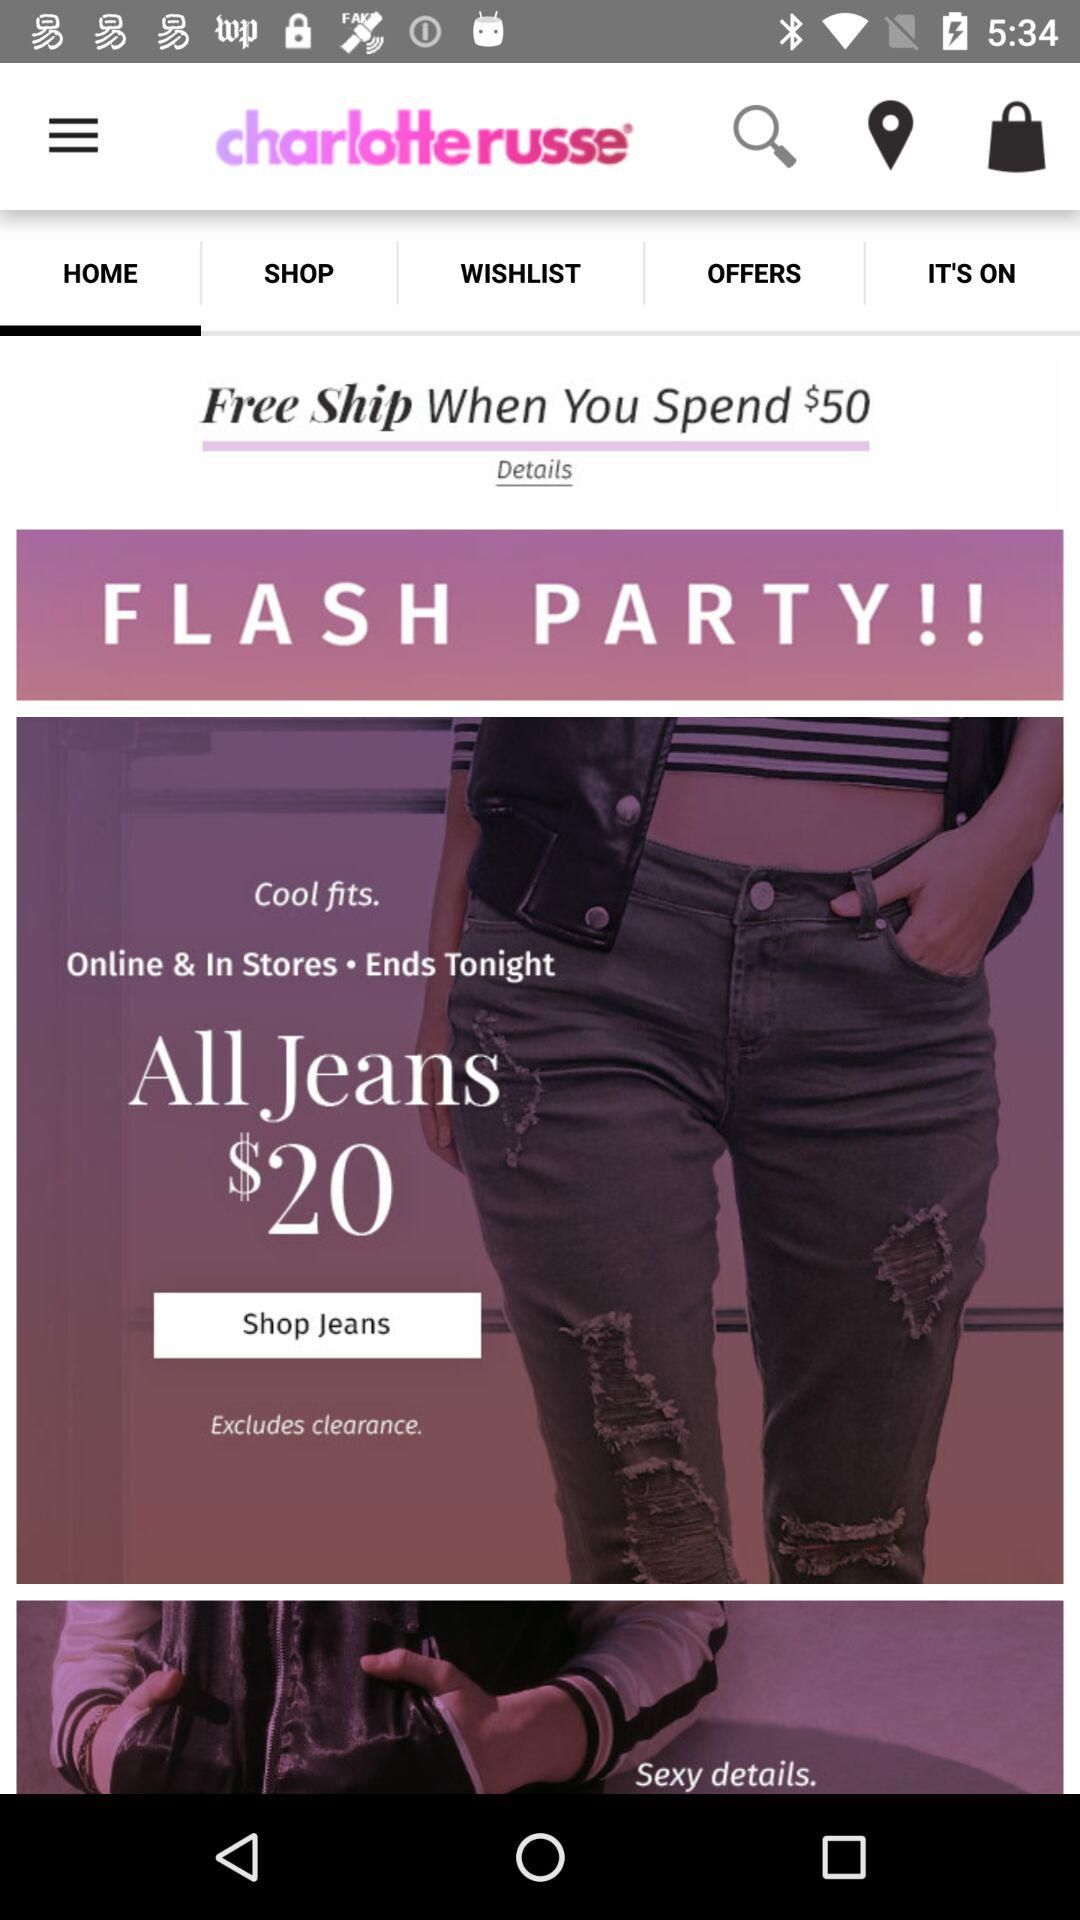When do we get free shipping? You get free shipping when you spend $50. 